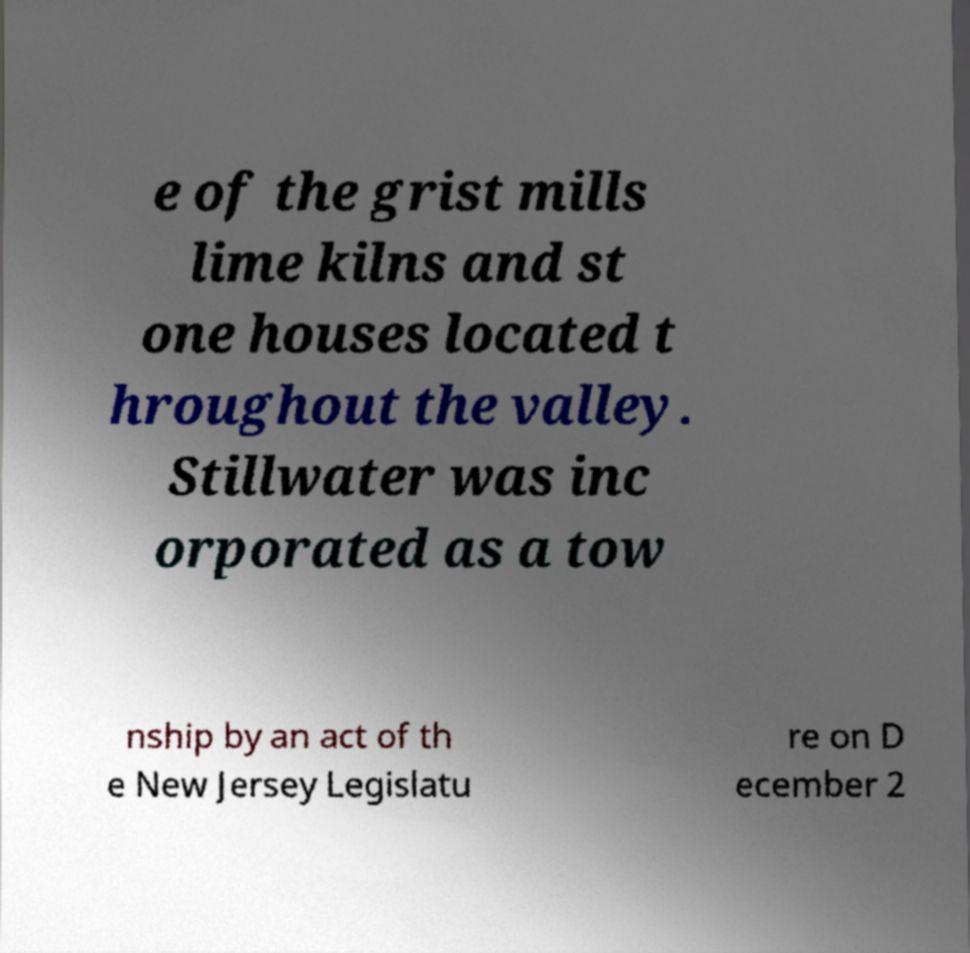Could you assist in decoding the text presented in this image and type it out clearly? e of the grist mills lime kilns and st one houses located t hroughout the valley. Stillwater was inc orporated as a tow nship by an act of th e New Jersey Legislatu re on D ecember 2 